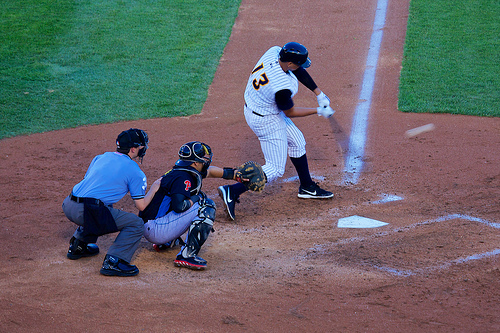Who is wearing the shield? The umpire, positioned behind the catcher, wears a protective shield as part of his gear. 